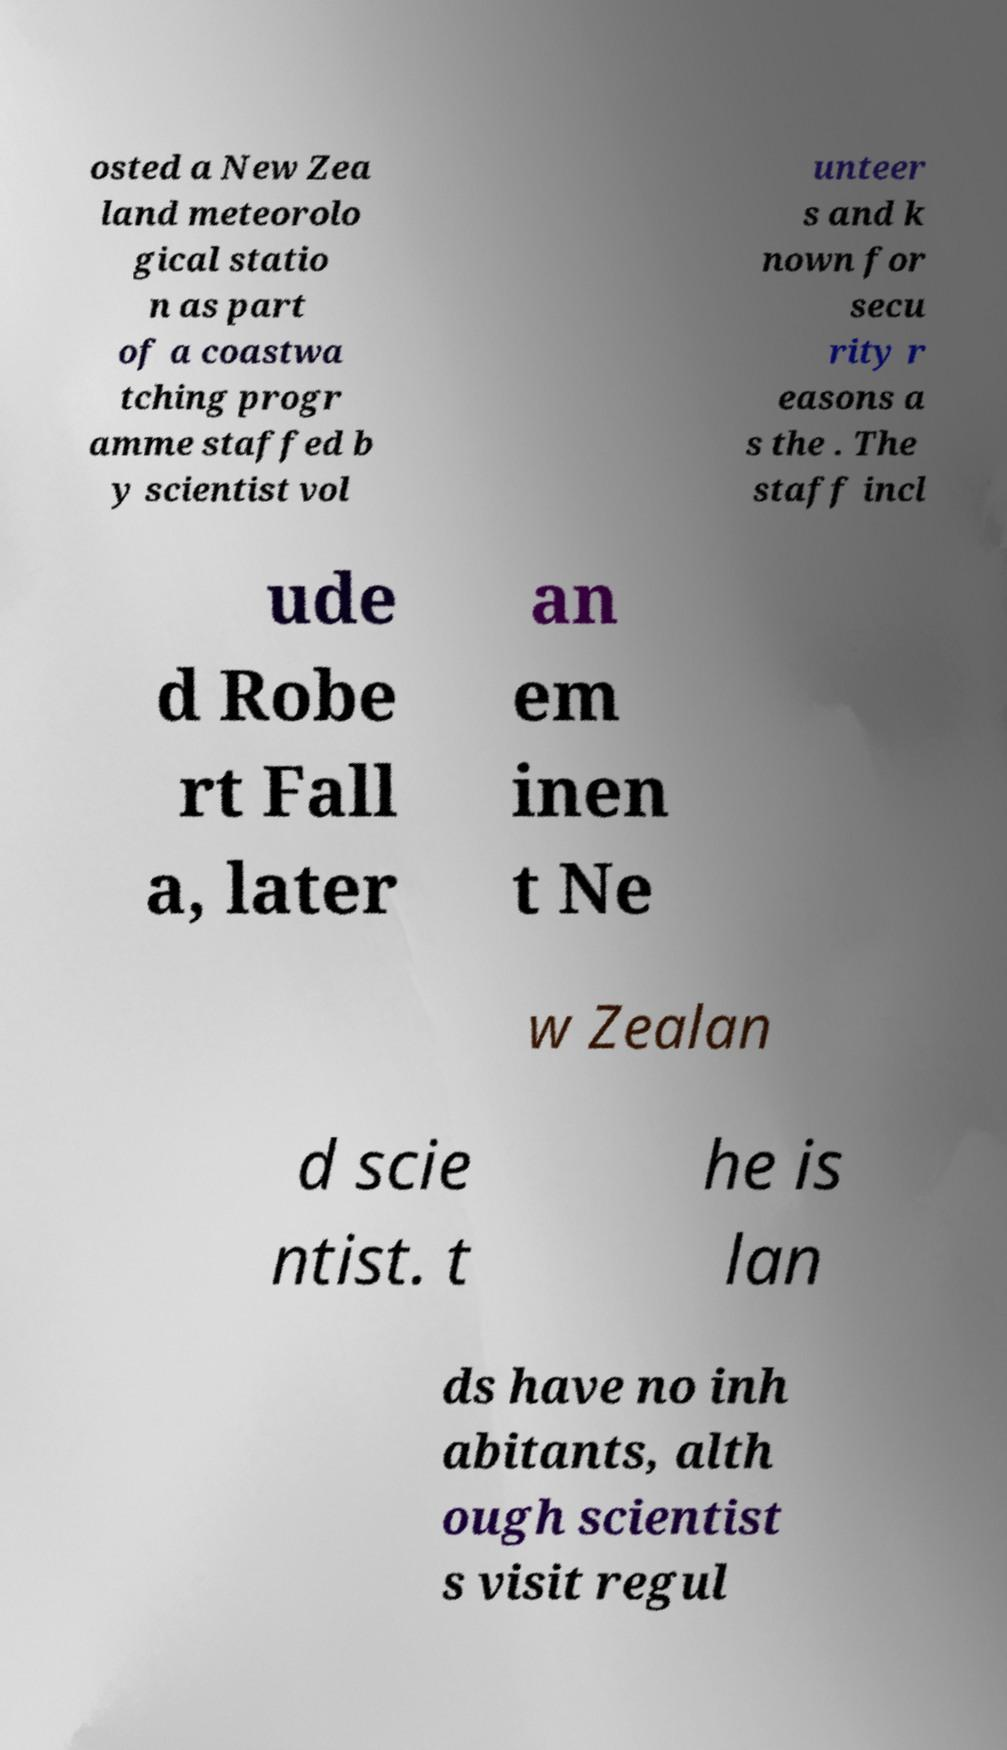I need the written content from this picture converted into text. Can you do that? osted a New Zea land meteorolo gical statio n as part of a coastwa tching progr amme staffed b y scientist vol unteer s and k nown for secu rity r easons a s the . The staff incl ude d Robe rt Fall a, later an em inen t Ne w Zealan d scie ntist. t he is lan ds have no inh abitants, alth ough scientist s visit regul 